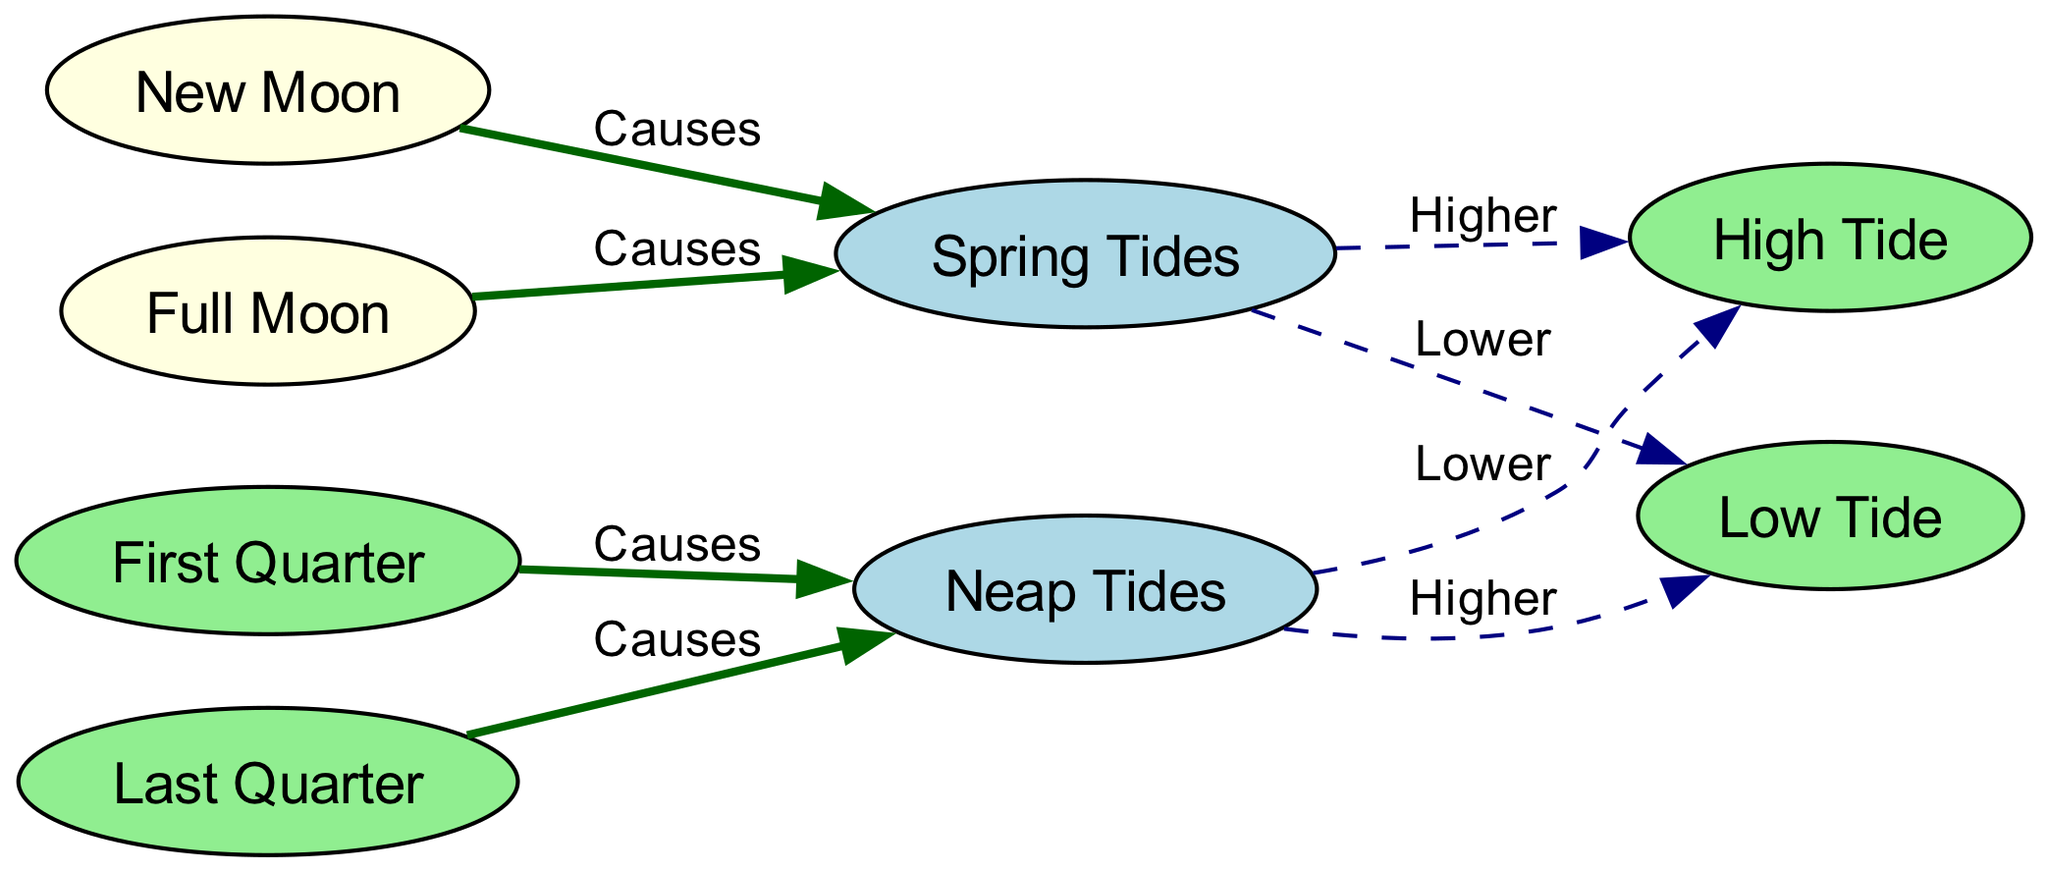What are the four moon phases shown in the diagram? The nodes labeled as moon phases in the diagram are 'New Moon', 'First Quarter', 'Full Moon', and 'Last Quarter'. By identifying each node related to moon phases, we can enumerate them.
Answer: New Moon, First Quarter, Full Moon, Last Quarter How many types of tides are indicated in the diagram? From the diagram, there are two types of tides represented: 'Spring Tides' and 'Neap Tides'. Counting the unique tide types confirms this.
Answer: Two Which moon phases cause Spring Tides? The diagram illustrates that both 'New Moon' and 'Full Moon' are connected to 'Spring Tides' with a 'Causes' label. Identifying these connections leads to the answer.
Answer: New Moon, Full Moon What happens to High Tide during Neap Tides? According to the diagram, 'Neap Tides' causes 'High Tide' to be 'Lower'. By traversing the edge from 'Neap Tides' to 'High Tide', we can deduce the impact.
Answer: Lower What types of tides occur during the Last Quarter? The diagram shows that the 'Last Quarter' phase causes 'Neap Tides'. By following the flow from 'Last Quarter', we identify 'Neap Tides' as the resulting tide type.
Answer: Neap Tides How many edges are connected to the New Moon node? The 'New Moon' node has one edge connecting it to 'Spring Tides', indicating it causes the tide. Counting the edges originating from this node allows us to ascertain the number.
Answer: One Which phase results in higher Low Tides? The diagram indicates that 'Neap Tides' results in 'Low Tide' being 'Higher'. By assessing the relationship, we find this information.
Answer: Neap Tides What is the effect of First Quarter on tides? The 'First Quarter' phase causes 'Neap Tides', which then influences the tide levels. Evaluating the connections between these nodes gives insight into the competitive impacts of moon phases on tidal heights.
Answer: Neap Tides 